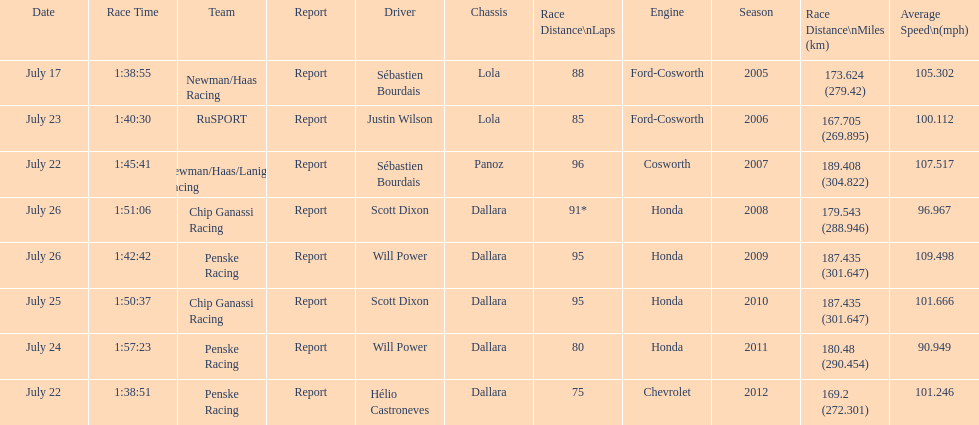How many different teams are represented in the table? 4. 